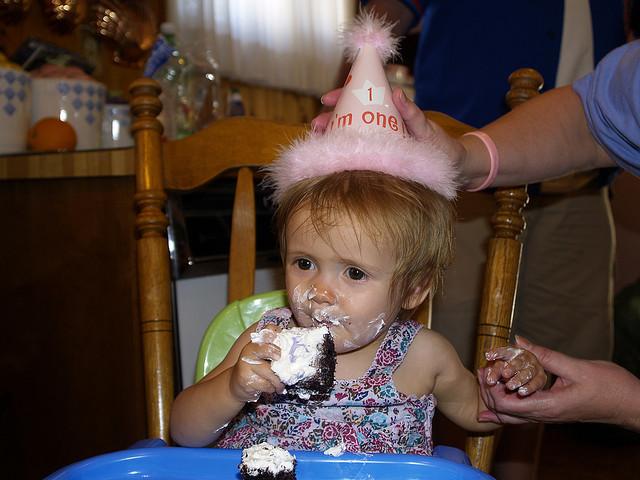What is on her head?
Keep it brief. Party hat. How old is the girl?
Answer briefly. 1. What is the girl eating?
Be succinct. Cake. 